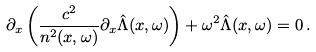Convert formula to latex. <formula><loc_0><loc_0><loc_500><loc_500>\partial _ { x } \left ( \frac { c ^ { 2 } } { n ^ { 2 } ( x , \omega ) } \partial _ { x } \hat { \Lambda } ( x , \omega ) \right ) + \omega ^ { 2 } \hat { \Lambda } ( x , \omega ) = 0 \, .</formula> 